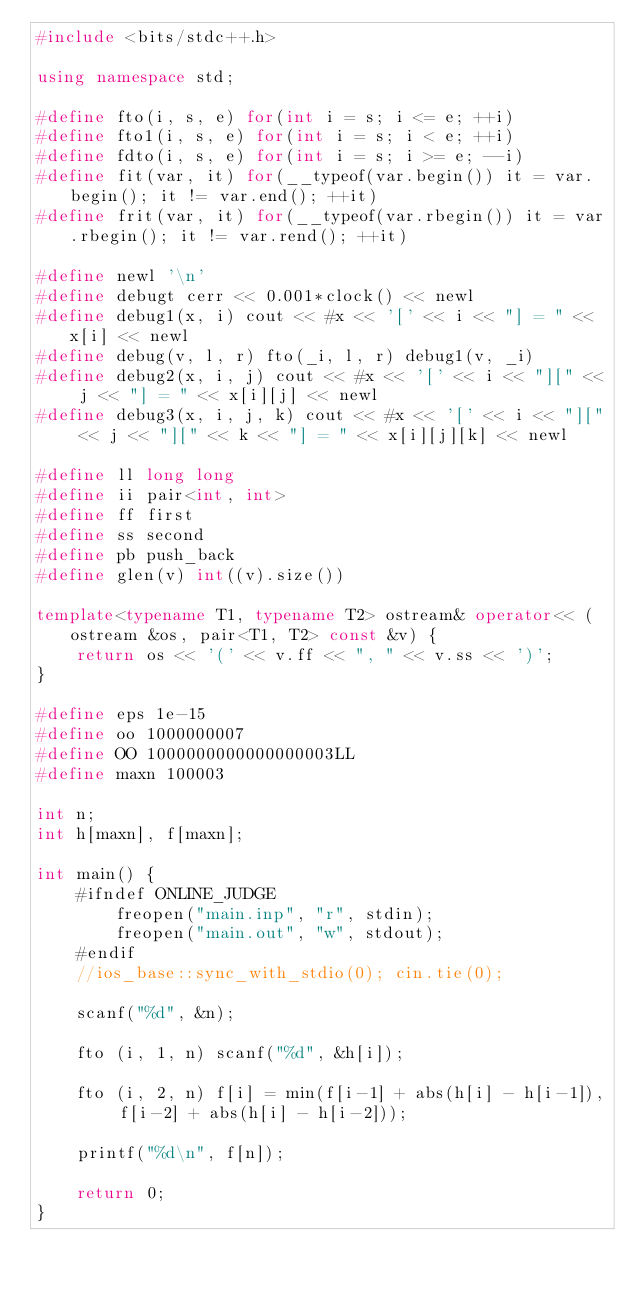<code> <loc_0><loc_0><loc_500><loc_500><_C++_>#include <bits/stdc++.h>

using namespace std;

#define fto(i, s, e) for(int i = s; i <= e; ++i)
#define fto1(i, s, e) for(int i = s; i < e; ++i)
#define fdto(i, s, e) for(int i = s; i >= e; --i)
#define fit(var, it) for(__typeof(var.begin()) it = var.begin(); it != var.end(); ++it)
#define frit(var, it) for(__typeof(var.rbegin()) it = var.rbegin(); it != var.rend(); ++it)

#define newl '\n'
#define debugt cerr << 0.001*clock() << newl
#define debug1(x, i) cout << #x << '[' << i << "] = " << x[i] << newl
#define debug(v, l, r) fto(_i, l, r) debug1(v, _i)
#define debug2(x, i, j) cout << #x << '[' << i << "][" << j << "] = " << x[i][j] << newl
#define debug3(x, i, j, k) cout << #x << '[' << i << "][" << j << "][" << k << "] = " << x[i][j][k] << newl

#define ll long long
#define ii pair<int, int>
#define ff first
#define ss second
#define pb push_back
#define glen(v) int((v).size())

template<typename T1, typename T2> ostream& operator<< (ostream &os, pair<T1, T2> const &v) {
	return os << '(' << v.ff << ", " << v.ss << ')';
}

#define eps 1e-15
#define oo 1000000007
#define OO 1000000000000000003LL
#define maxn 100003

int n;
int h[maxn], f[maxn];

int main() {
	#ifndef ONLINE_JUDGE
		freopen("main.inp", "r", stdin);
		freopen("main.out", "w", stdout);
	#endif
	//ios_base::sync_with_stdio(0); cin.tie(0);

	scanf("%d", &n);

	fto (i, 1, n) scanf("%d", &h[i]);

	fto (i, 2, n) f[i] = min(f[i-1] + abs(h[i] - h[i-1]), f[i-2] + abs(h[i] - h[i-2]));

	printf("%d\n", f[n]);

	return 0;
}
</code> 